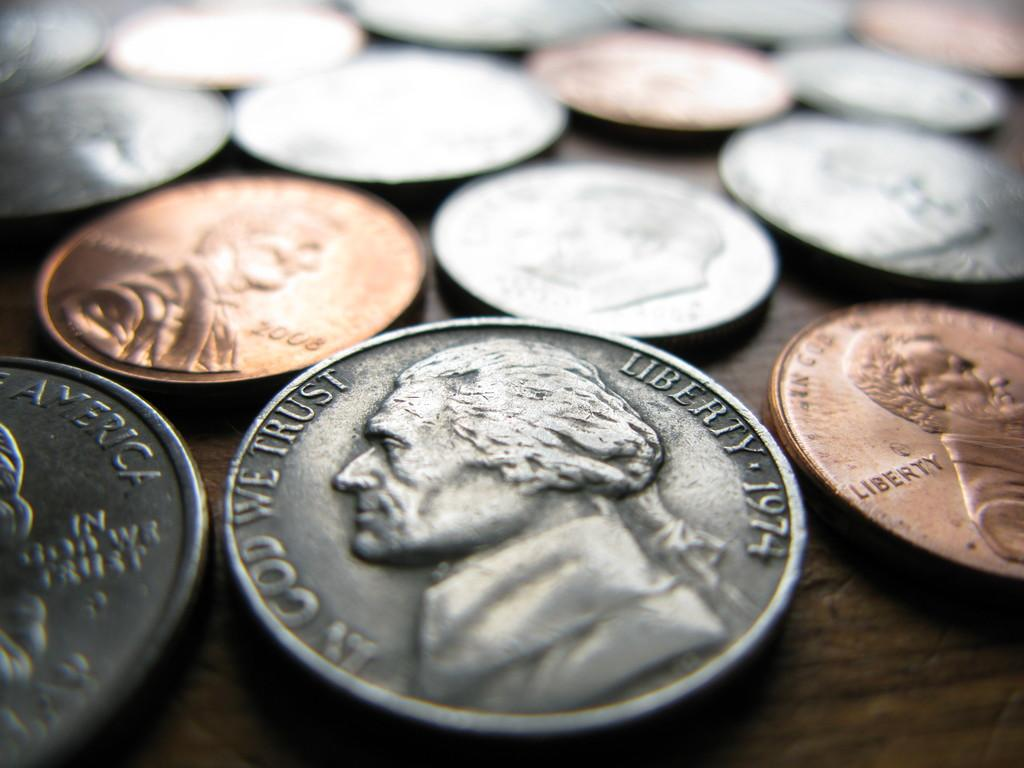Provide a one-sentence caption for the provided image. A number of coins sits on a table, with the one most in the foreground dated 1974. 